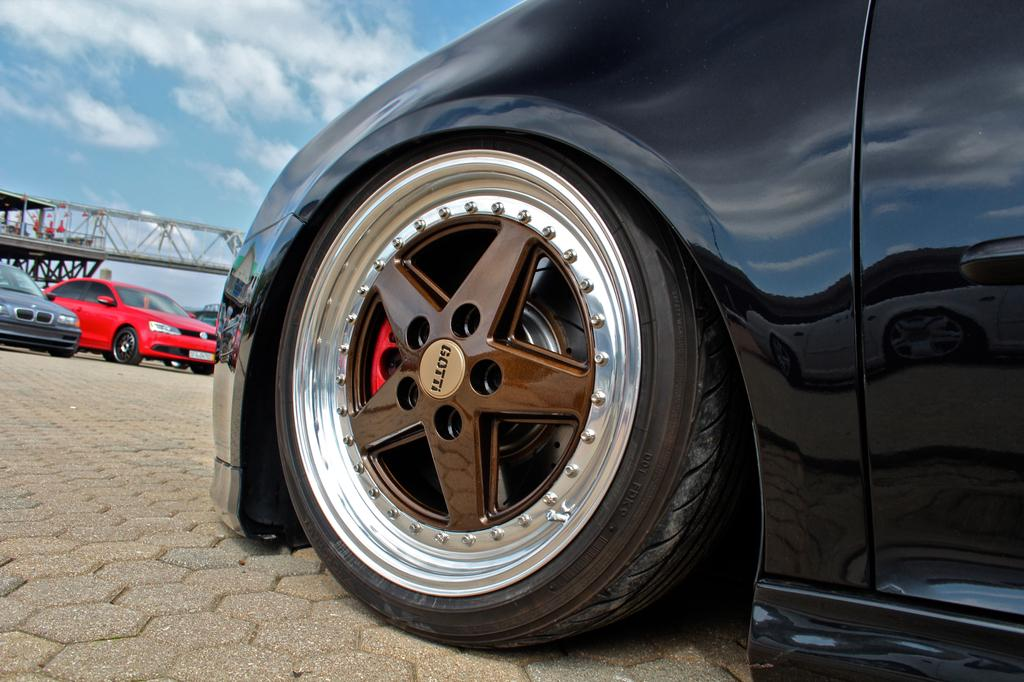What types of vehicles can be seen in the image? There are vehicles in the image, but the specific types are not mentioned. What structure is present in the image? There is a bridge in the image. Can you describe any other objects in the image? There are unspecified objects in the image. What is visible in the background of the image? The sky is visible in the background of the image. What can be seen in the sky? Clouds are present in the sky. What knowledge does the tongue possess in the image? There is no tongue present in the image, so it is not possible to determine what knowledge it might possess. What is the name of the person who created the image? The name of the person who created the image is not mentioned in the provided facts, so it cannot be determined. 